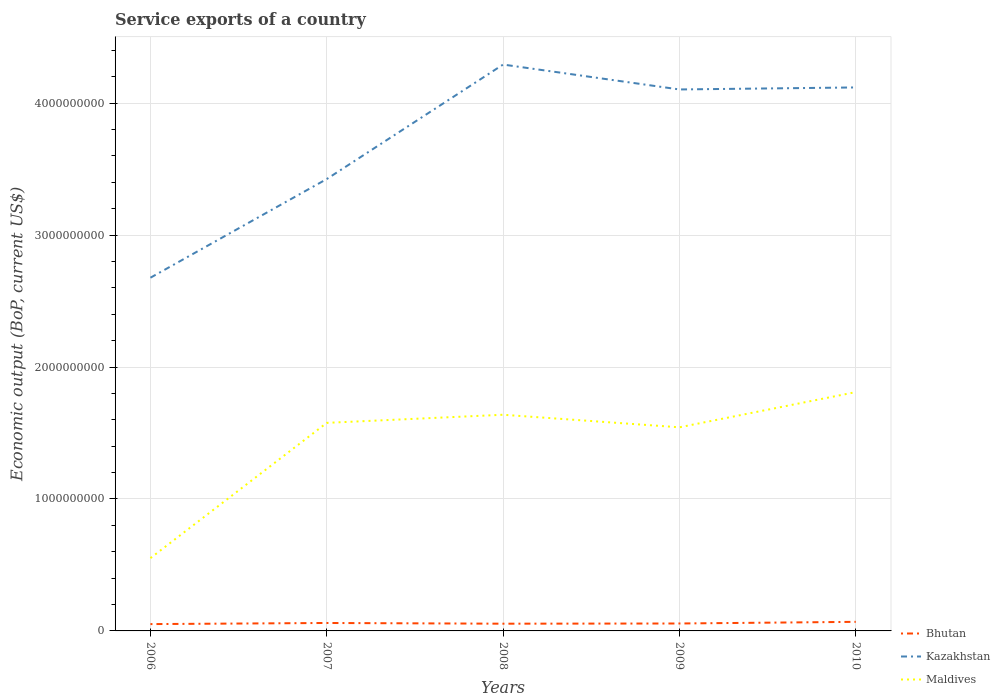Is the number of lines equal to the number of legend labels?
Ensure brevity in your answer.  Yes. Across all years, what is the maximum service exports in Kazakhstan?
Offer a very short reply. 2.68e+09. What is the total service exports in Maldives in the graph?
Ensure brevity in your answer.  3.38e+07. What is the difference between the highest and the second highest service exports in Bhutan?
Provide a succinct answer. 1.71e+07. What is the difference between the highest and the lowest service exports in Maldives?
Give a very brief answer. 4. How many lines are there?
Your answer should be very brief. 3. What is the difference between two consecutive major ticks on the Y-axis?
Your answer should be compact. 1.00e+09. Are the values on the major ticks of Y-axis written in scientific E-notation?
Make the answer very short. No. Does the graph contain grids?
Provide a short and direct response. Yes. What is the title of the graph?
Make the answer very short. Service exports of a country. What is the label or title of the Y-axis?
Keep it short and to the point. Economic output (BoP, current US$). What is the Economic output (BoP, current US$) of Bhutan in 2006?
Offer a terse response. 5.17e+07. What is the Economic output (BoP, current US$) of Kazakhstan in 2006?
Offer a very short reply. 2.68e+09. What is the Economic output (BoP, current US$) in Maldives in 2006?
Give a very brief answer. 5.52e+08. What is the Economic output (BoP, current US$) in Bhutan in 2007?
Your response must be concise. 6.02e+07. What is the Economic output (BoP, current US$) of Kazakhstan in 2007?
Your answer should be compact. 3.42e+09. What is the Economic output (BoP, current US$) in Maldives in 2007?
Your answer should be compact. 1.58e+09. What is the Economic output (BoP, current US$) in Bhutan in 2008?
Provide a succinct answer. 5.48e+07. What is the Economic output (BoP, current US$) of Kazakhstan in 2008?
Provide a short and direct response. 4.29e+09. What is the Economic output (BoP, current US$) of Maldives in 2008?
Your response must be concise. 1.64e+09. What is the Economic output (BoP, current US$) of Bhutan in 2009?
Your answer should be compact. 5.63e+07. What is the Economic output (BoP, current US$) in Kazakhstan in 2009?
Offer a terse response. 4.10e+09. What is the Economic output (BoP, current US$) of Maldives in 2009?
Ensure brevity in your answer.  1.54e+09. What is the Economic output (BoP, current US$) of Bhutan in 2010?
Provide a succinct answer. 6.88e+07. What is the Economic output (BoP, current US$) in Kazakhstan in 2010?
Your response must be concise. 4.12e+09. What is the Economic output (BoP, current US$) of Maldives in 2010?
Provide a succinct answer. 1.81e+09. Across all years, what is the maximum Economic output (BoP, current US$) of Bhutan?
Offer a terse response. 6.88e+07. Across all years, what is the maximum Economic output (BoP, current US$) in Kazakhstan?
Provide a short and direct response. 4.29e+09. Across all years, what is the maximum Economic output (BoP, current US$) in Maldives?
Keep it short and to the point. 1.81e+09. Across all years, what is the minimum Economic output (BoP, current US$) in Bhutan?
Your response must be concise. 5.17e+07. Across all years, what is the minimum Economic output (BoP, current US$) in Kazakhstan?
Provide a short and direct response. 2.68e+09. Across all years, what is the minimum Economic output (BoP, current US$) of Maldives?
Make the answer very short. 5.52e+08. What is the total Economic output (BoP, current US$) of Bhutan in the graph?
Your answer should be very brief. 2.92e+08. What is the total Economic output (BoP, current US$) of Kazakhstan in the graph?
Your answer should be compact. 1.86e+1. What is the total Economic output (BoP, current US$) in Maldives in the graph?
Your answer should be compact. 7.12e+09. What is the difference between the Economic output (BoP, current US$) in Bhutan in 2006 and that in 2007?
Offer a very short reply. -8.47e+06. What is the difference between the Economic output (BoP, current US$) of Kazakhstan in 2006 and that in 2007?
Offer a very short reply. -7.48e+08. What is the difference between the Economic output (BoP, current US$) of Maldives in 2006 and that in 2007?
Give a very brief answer. -1.03e+09. What is the difference between the Economic output (BoP, current US$) in Bhutan in 2006 and that in 2008?
Your response must be concise. -3.05e+06. What is the difference between the Economic output (BoP, current US$) in Kazakhstan in 2006 and that in 2008?
Offer a very short reply. -1.62e+09. What is the difference between the Economic output (BoP, current US$) in Maldives in 2006 and that in 2008?
Make the answer very short. -1.09e+09. What is the difference between the Economic output (BoP, current US$) in Bhutan in 2006 and that in 2009?
Your response must be concise. -4.60e+06. What is the difference between the Economic output (BoP, current US$) of Kazakhstan in 2006 and that in 2009?
Make the answer very short. -1.43e+09. What is the difference between the Economic output (BoP, current US$) in Maldives in 2006 and that in 2009?
Provide a succinct answer. -9.91e+08. What is the difference between the Economic output (BoP, current US$) of Bhutan in 2006 and that in 2010?
Ensure brevity in your answer.  -1.71e+07. What is the difference between the Economic output (BoP, current US$) in Kazakhstan in 2006 and that in 2010?
Give a very brief answer. -1.44e+09. What is the difference between the Economic output (BoP, current US$) in Maldives in 2006 and that in 2010?
Keep it short and to the point. -1.26e+09. What is the difference between the Economic output (BoP, current US$) of Bhutan in 2007 and that in 2008?
Provide a short and direct response. 5.42e+06. What is the difference between the Economic output (BoP, current US$) of Kazakhstan in 2007 and that in 2008?
Your response must be concise. -8.68e+08. What is the difference between the Economic output (BoP, current US$) in Maldives in 2007 and that in 2008?
Provide a succinct answer. -6.14e+07. What is the difference between the Economic output (BoP, current US$) of Bhutan in 2007 and that in 2009?
Your response must be concise. 3.88e+06. What is the difference between the Economic output (BoP, current US$) of Kazakhstan in 2007 and that in 2009?
Your response must be concise. -6.79e+08. What is the difference between the Economic output (BoP, current US$) of Maldives in 2007 and that in 2009?
Provide a short and direct response. 3.38e+07. What is the difference between the Economic output (BoP, current US$) in Bhutan in 2007 and that in 2010?
Provide a short and direct response. -8.64e+06. What is the difference between the Economic output (BoP, current US$) of Kazakhstan in 2007 and that in 2010?
Offer a very short reply. -6.94e+08. What is the difference between the Economic output (BoP, current US$) of Maldives in 2007 and that in 2010?
Provide a succinct answer. -2.33e+08. What is the difference between the Economic output (BoP, current US$) of Bhutan in 2008 and that in 2009?
Offer a very short reply. -1.55e+06. What is the difference between the Economic output (BoP, current US$) of Kazakhstan in 2008 and that in 2009?
Your response must be concise. 1.89e+08. What is the difference between the Economic output (BoP, current US$) of Maldives in 2008 and that in 2009?
Keep it short and to the point. 9.52e+07. What is the difference between the Economic output (BoP, current US$) in Bhutan in 2008 and that in 2010?
Provide a succinct answer. -1.41e+07. What is the difference between the Economic output (BoP, current US$) in Kazakhstan in 2008 and that in 2010?
Provide a succinct answer. 1.73e+08. What is the difference between the Economic output (BoP, current US$) in Maldives in 2008 and that in 2010?
Offer a terse response. -1.72e+08. What is the difference between the Economic output (BoP, current US$) in Bhutan in 2009 and that in 2010?
Your answer should be very brief. -1.25e+07. What is the difference between the Economic output (BoP, current US$) of Kazakhstan in 2009 and that in 2010?
Give a very brief answer. -1.53e+07. What is the difference between the Economic output (BoP, current US$) in Maldives in 2009 and that in 2010?
Your response must be concise. -2.67e+08. What is the difference between the Economic output (BoP, current US$) in Bhutan in 2006 and the Economic output (BoP, current US$) in Kazakhstan in 2007?
Keep it short and to the point. -3.37e+09. What is the difference between the Economic output (BoP, current US$) in Bhutan in 2006 and the Economic output (BoP, current US$) in Maldives in 2007?
Make the answer very short. -1.53e+09. What is the difference between the Economic output (BoP, current US$) of Kazakhstan in 2006 and the Economic output (BoP, current US$) of Maldives in 2007?
Give a very brief answer. 1.10e+09. What is the difference between the Economic output (BoP, current US$) of Bhutan in 2006 and the Economic output (BoP, current US$) of Kazakhstan in 2008?
Make the answer very short. -4.24e+09. What is the difference between the Economic output (BoP, current US$) in Bhutan in 2006 and the Economic output (BoP, current US$) in Maldives in 2008?
Your response must be concise. -1.59e+09. What is the difference between the Economic output (BoP, current US$) of Kazakhstan in 2006 and the Economic output (BoP, current US$) of Maldives in 2008?
Keep it short and to the point. 1.04e+09. What is the difference between the Economic output (BoP, current US$) of Bhutan in 2006 and the Economic output (BoP, current US$) of Kazakhstan in 2009?
Your response must be concise. -4.05e+09. What is the difference between the Economic output (BoP, current US$) in Bhutan in 2006 and the Economic output (BoP, current US$) in Maldives in 2009?
Provide a succinct answer. -1.49e+09. What is the difference between the Economic output (BoP, current US$) in Kazakhstan in 2006 and the Economic output (BoP, current US$) in Maldives in 2009?
Offer a very short reply. 1.13e+09. What is the difference between the Economic output (BoP, current US$) in Bhutan in 2006 and the Economic output (BoP, current US$) in Kazakhstan in 2010?
Make the answer very short. -4.07e+09. What is the difference between the Economic output (BoP, current US$) in Bhutan in 2006 and the Economic output (BoP, current US$) in Maldives in 2010?
Offer a terse response. -1.76e+09. What is the difference between the Economic output (BoP, current US$) of Kazakhstan in 2006 and the Economic output (BoP, current US$) of Maldives in 2010?
Your response must be concise. 8.67e+08. What is the difference between the Economic output (BoP, current US$) in Bhutan in 2007 and the Economic output (BoP, current US$) in Kazakhstan in 2008?
Your answer should be compact. -4.23e+09. What is the difference between the Economic output (BoP, current US$) in Bhutan in 2007 and the Economic output (BoP, current US$) in Maldives in 2008?
Give a very brief answer. -1.58e+09. What is the difference between the Economic output (BoP, current US$) in Kazakhstan in 2007 and the Economic output (BoP, current US$) in Maldives in 2008?
Your answer should be very brief. 1.79e+09. What is the difference between the Economic output (BoP, current US$) in Bhutan in 2007 and the Economic output (BoP, current US$) in Kazakhstan in 2009?
Keep it short and to the point. -4.04e+09. What is the difference between the Economic output (BoP, current US$) in Bhutan in 2007 and the Economic output (BoP, current US$) in Maldives in 2009?
Provide a short and direct response. -1.48e+09. What is the difference between the Economic output (BoP, current US$) of Kazakhstan in 2007 and the Economic output (BoP, current US$) of Maldives in 2009?
Keep it short and to the point. 1.88e+09. What is the difference between the Economic output (BoP, current US$) in Bhutan in 2007 and the Economic output (BoP, current US$) in Kazakhstan in 2010?
Offer a very short reply. -4.06e+09. What is the difference between the Economic output (BoP, current US$) in Bhutan in 2007 and the Economic output (BoP, current US$) in Maldives in 2010?
Your answer should be compact. -1.75e+09. What is the difference between the Economic output (BoP, current US$) of Kazakhstan in 2007 and the Economic output (BoP, current US$) of Maldives in 2010?
Your answer should be compact. 1.61e+09. What is the difference between the Economic output (BoP, current US$) in Bhutan in 2008 and the Economic output (BoP, current US$) in Kazakhstan in 2009?
Give a very brief answer. -4.05e+09. What is the difference between the Economic output (BoP, current US$) in Bhutan in 2008 and the Economic output (BoP, current US$) in Maldives in 2009?
Your answer should be compact. -1.49e+09. What is the difference between the Economic output (BoP, current US$) of Kazakhstan in 2008 and the Economic output (BoP, current US$) of Maldives in 2009?
Offer a very short reply. 2.75e+09. What is the difference between the Economic output (BoP, current US$) in Bhutan in 2008 and the Economic output (BoP, current US$) in Kazakhstan in 2010?
Give a very brief answer. -4.06e+09. What is the difference between the Economic output (BoP, current US$) of Bhutan in 2008 and the Economic output (BoP, current US$) of Maldives in 2010?
Your response must be concise. -1.76e+09. What is the difference between the Economic output (BoP, current US$) in Kazakhstan in 2008 and the Economic output (BoP, current US$) in Maldives in 2010?
Your answer should be compact. 2.48e+09. What is the difference between the Economic output (BoP, current US$) in Bhutan in 2009 and the Economic output (BoP, current US$) in Kazakhstan in 2010?
Ensure brevity in your answer.  -4.06e+09. What is the difference between the Economic output (BoP, current US$) in Bhutan in 2009 and the Economic output (BoP, current US$) in Maldives in 2010?
Offer a very short reply. -1.75e+09. What is the difference between the Economic output (BoP, current US$) in Kazakhstan in 2009 and the Economic output (BoP, current US$) in Maldives in 2010?
Keep it short and to the point. 2.29e+09. What is the average Economic output (BoP, current US$) in Bhutan per year?
Offer a very short reply. 5.84e+07. What is the average Economic output (BoP, current US$) in Kazakhstan per year?
Provide a succinct answer. 3.72e+09. What is the average Economic output (BoP, current US$) of Maldives per year?
Make the answer very short. 1.42e+09. In the year 2006, what is the difference between the Economic output (BoP, current US$) in Bhutan and Economic output (BoP, current US$) in Kazakhstan?
Your response must be concise. -2.63e+09. In the year 2006, what is the difference between the Economic output (BoP, current US$) in Bhutan and Economic output (BoP, current US$) in Maldives?
Your answer should be compact. -5.00e+08. In the year 2006, what is the difference between the Economic output (BoP, current US$) in Kazakhstan and Economic output (BoP, current US$) in Maldives?
Your response must be concise. 2.13e+09. In the year 2007, what is the difference between the Economic output (BoP, current US$) of Bhutan and Economic output (BoP, current US$) of Kazakhstan?
Your response must be concise. -3.36e+09. In the year 2007, what is the difference between the Economic output (BoP, current US$) of Bhutan and Economic output (BoP, current US$) of Maldives?
Provide a succinct answer. -1.52e+09. In the year 2007, what is the difference between the Economic output (BoP, current US$) in Kazakhstan and Economic output (BoP, current US$) in Maldives?
Your answer should be very brief. 1.85e+09. In the year 2008, what is the difference between the Economic output (BoP, current US$) in Bhutan and Economic output (BoP, current US$) in Kazakhstan?
Your response must be concise. -4.24e+09. In the year 2008, what is the difference between the Economic output (BoP, current US$) in Bhutan and Economic output (BoP, current US$) in Maldives?
Offer a terse response. -1.58e+09. In the year 2008, what is the difference between the Economic output (BoP, current US$) of Kazakhstan and Economic output (BoP, current US$) of Maldives?
Your answer should be compact. 2.65e+09. In the year 2009, what is the difference between the Economic output (BoP, current US$) in Bhutan and Economic output (BoP, current US$) in Kazakhstan?
Offer a very short reply. -4.05e+09. In the year 2009, what is the difference between the Economic output (BoP, current US$) of Bhutan and Economic output (BoP, current US$) of Maldives?
Give a very brief answer. -1.49e+09. In the year 2009, what is the difference between the Economic output (BoP, current US$) of Kazakhstan and Economic output (BoP, current US$) of Maldives?
Provide a short and direct response. 2.56e+09. In the year 2010, what is the difference between the Economic output (BoP, current US$) of Bhutan and Economic output (BoP, current US$) of Kazakhstan?
Give a very brief answer. -4.05e+09. In the year 2010, what is the difference between the Economic output (BoP, current US$) in Bhutan and Economic output (BoP, current US$) in Maldives?
Provide a short and direct response. -1.74e+09. In the year 2010, what is the difference between the Economic output (BoP, current US$) in Kazakhstan and Economic output (BoP, current US$) in Maldives?
Your answer should be compact. 2.31e+09. What is the ratio of the Economic output (BoP, current US$) of Bhutan in 2006 to that in 2007?
Your answer should be compact. 0.86. What is the ratio of the Economic output (BoP, current US$) of Kazakhstan in 2006 to that in 2007?
Offer a terse response. 0.78. What is the ratio of the Economic output (BoP, current US$) in Maldives in 2006 to that in 2007?
Offer a terse response. 0.35. What is the ratio of the Economic output (BoP, current US$) in Bhutan in 2006 to that in 2008?
Offer a terse response. 0.94. What is the ratio of the Economic output (BoP, current US$) in Kazakhstan in 2006 to that in 2008?
Keep it short and to the point. 0.62. What is the ratio of the Economic output (BoP, current US$) in Maldives in 2006 to that in 2008?
Your answer should be compact. 0.34. What is the ratio of the Economic output (BoP, current US$) in Bhutan in 2006 to that in 2009?
Provide a short and direct response. 0.92. What is the ratio of the Economic output (BoP, current US$) of Kazakhstan in 2006 to that in 2009?
Your answer should be compact. 0.65. What is the ratio of the Economic output (BoP, current US$) in Maldives in 2006 to that in 2009?
Offer a very short reply. 0.36. What is the ratio of the Economic output (BoP, current US$) of Bhutan in 2006 to that in 2010?
Provide a succinct answer. 0.75. What is the ratio of the Economic output (BoP, current US$) of Kazakhstan in 2006 to that in 2010?
Keep it short and to the point. 0.65. What is the ratio of the Economic output (BoP, current US$) of Maldives in 2006 to that in 2010?
Ensure brevity in your answer.  0.3. What is the ratio of the Economic output (BoP, current US$) of Bhutan in 2007 to that in 2008?
Provide a succinct answer. 1.1. What is the ratio of the Economic output (BoP, current US$) of Kazakhstan in 2007 to that in 2008?
Offer a very short reply. 0.8. What is the ratio of the Economic output (BoP, current US$) in Maldives in 2007 to that in 2008?
Your answer should be very brief. 0.96. What is the ratio of the Economic output (BoP, current US$) of Bhutan in 2007 to that in 2009?
Provide a succinct answer. 1.07. What is the ratio of the Economic output (BoP, current US$) of Kazakhstan in 2007 to that in 2009?
Your answer should be compact. 0.83. What is the ratio of the Economic output (BoP, current US$) of Maldives in 2007 to that in 2009?
Provide a short and direct response. 1.02. What is the ratio of the Economic output (BoP, current US$) of Bhutan in 2007 to that in 2010?
Offer a very short reply. 0.87. What is the ratio of the Economic output (BoP, current US$) in Kazakhstan in 2007 to that in 2010?
Keep it short and to the point. 0.83. What is the ratio of the Economic output (BoP, current US$) of Maldives in 2007 to that in 2010?
Provide a succinct answer. 0.87. What is the ratio of the Economic output (BoP, current US$) in Bhutan in 2008 to that in 2009?
Give a very brief answer. 0.97. What is the ratio of the Economic output (BoP, current US$) in Kazakhstan in 2008 to that in 2009?
Provide a succinct answer. 1.05. What is the ratio of the Economic output (BoP, current US$) of Maldives in 2008 to that in 2009?
Your response must be concise. 1.06. What is the ratio of the Economic output (BoP, current US$) of Bhutan in 2008 to that in 2010?
Keep it short and to the point. 0.8. What is the ratio of the Economic output (BoP, current US$) in Kazakhstan in 2008 to that in 2010?
Offer a very short reply. 1.04. What is the ratio of the Economic output (BoP, current US$) in Maldives in 2008 to that in 2010?
Your answer should be very brief. 0.91. What is the ratio of the Economic output (BoP, current US$) in Bhutan in 2009 to that in 2010?
Your response must be concise. 0.82. What is the ratio of the Economic output (BoP, current US$) in Kazakhstan in 2009 to that in 2010?
Offer a very short reply. 1. What is the ratio of the Economic output (BoP, current US$) in Maldives in 2009 to that in 2010?
Your response must be concise. 0.85. What is the difference between the highest and the second highest Economic output (BoP, current US$) in Bhutan?
Give a very brief answer. 8.64e+06. What is the difference between the highest and the second highest Economic output (BoP, current US$) in Kazakhstan?
Provide a succinct answer. 1.73e+08. What is the difference between the highest and the second highest Economic output (BoP, current US$) of Maldives?
Offer a terse response. 1.72e+08. What is the difference between the highest and the lowest Economic output (BoP, current US$) in Bhutan?
Offer a very short reply. 1.71e+07. What is the difference between the highest and the lowest Economic output (BoP, current US$) of Kazakhstan?
Offer a very short reply. 1.62e+09. What is the difference between the highest and the lowest Economic output (BoP, current US$) in Maldives?
Offer a very short reply. 1.26e+09. 